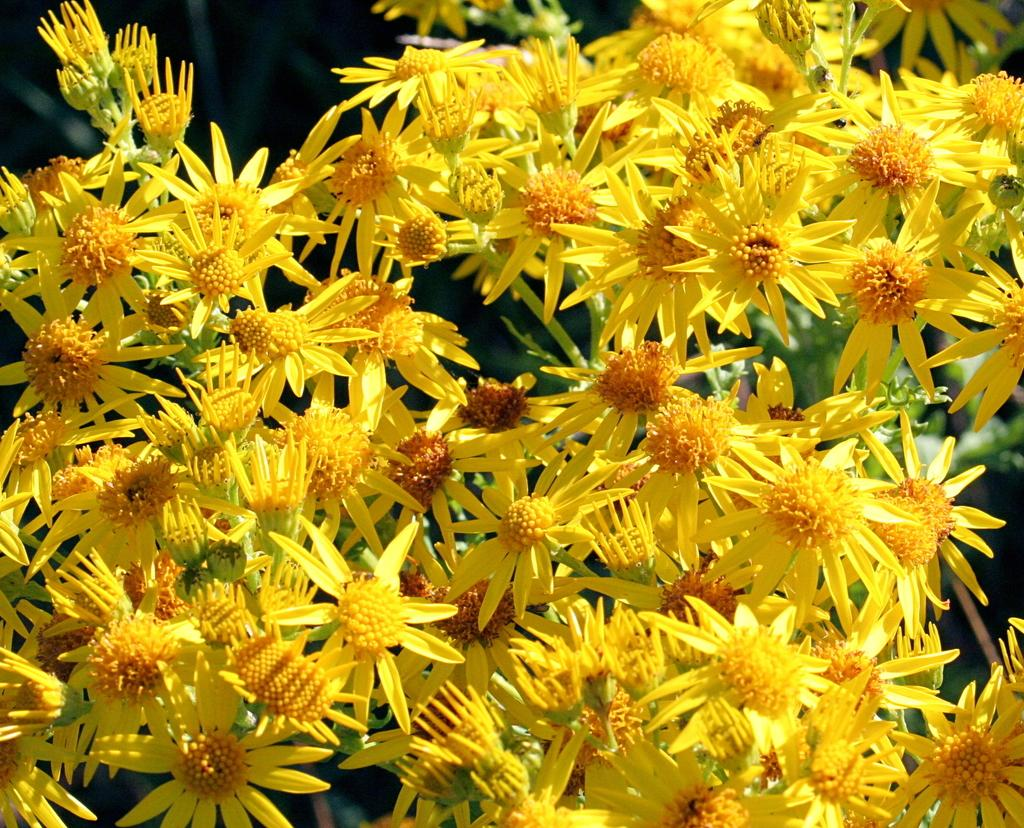What is present in the image? There are flowers in the image. Can you describe the background of the image? The background of the image is blurry. What type of dress is the flower wearing in the image? There are no dresses or people present in the image, as it features flowers and a blurry background. 